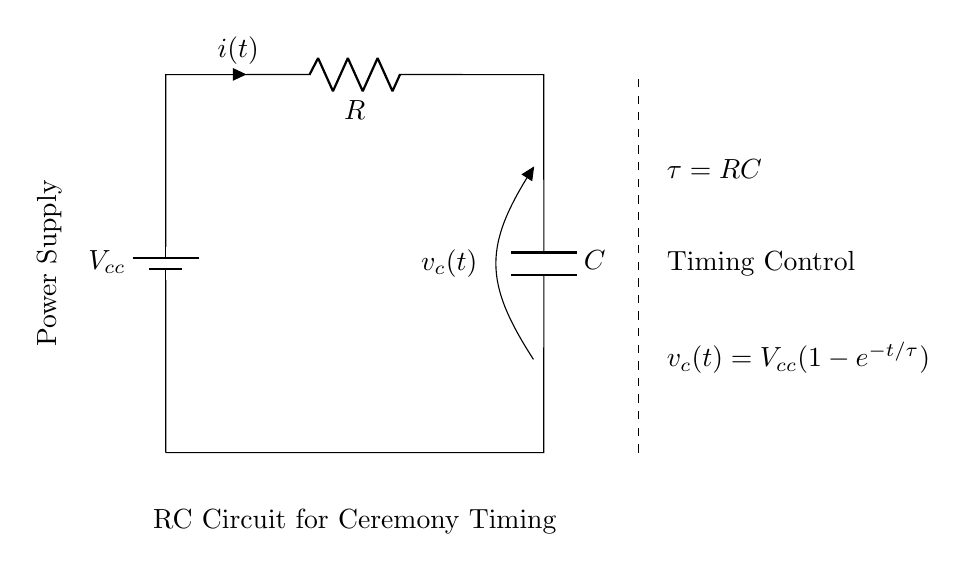What components are in this RC circuit? The circuit includes a battery, a resistor, and a capacitor. These components are necessary for the basic operation of the RC (Resistor-Capacitor) circuit.
Answer: battery, resistor, capacitor What is the time constant of this circuit? The time constant is indicated by the equation τ = RC, which is shown in the circuit diagram. The time constant of an RC circuit is a crucial parameter that characterizes the speed of charging and discharging of the capacitor.
Answer: RC What is the voltage across the capacitor at time t? The voltage \(v_c(t)\) across the capacitor is given by the equation \(v_c(t) = V_{cc}(1-e^{-t/\tau})\). This equation describes how the voltage across the capacitor increases over time as it charges.
Answer: Vcc(1-e^(-t/RC)) How does the current change over time in this circuit? The current \(i(t)\) flowing through the resistor decreases over time as the capacitor charges. Initially, it is at maximum but approaches zero as the capacitor becomes fully charged, demonstrating the exponential nature of charging in an RC circuit.
Answer: Decreases What role does the timing control play in this circuit? The timing control, indicated by the dashed line, suggests that the circuit is designed for regulating or measuring time delays. This aspect is essential for religious rituals, where precise timing is often significant.
Answer: Timing regulation What happens to the time constant if the resistance is doubled? If the resistance is doubled while keeping the capacitance constant, the time constant τ would also double according to the equation τ = RC. This means that the charging and discharging times of the capacitor would increase correspondingly.
Answer: Doubles 